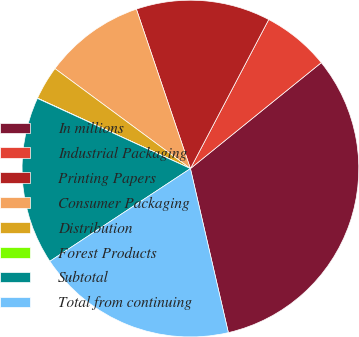<chart> <loc_0><loc_0><loc_500><loc_500><pie_chart><fcel>In millions<fcel>Industrial Packaging<fcel>Printing Papers<fcel>Consumer Packaging<fcel>Distribution<fcel>Forest Products<fcel>Subtotal<fcel>Total from continuing<nl><fcel>32.21%<fcel>6.47%<fcel>12.9%<fcel>9.68%<fcel>3.25%<fcel>0.03%<fcel>16.12%<fcel>19.34%<nl></chart> 